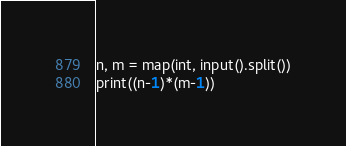<code> <loc_0><loc_0><loc_500><loc_500><_Python_>n, m = map(int, input().split())
print((n-1)*(m-1))
</code> 